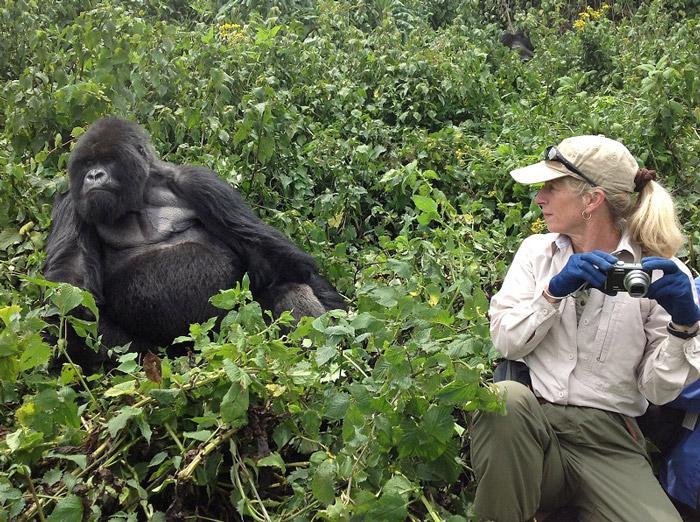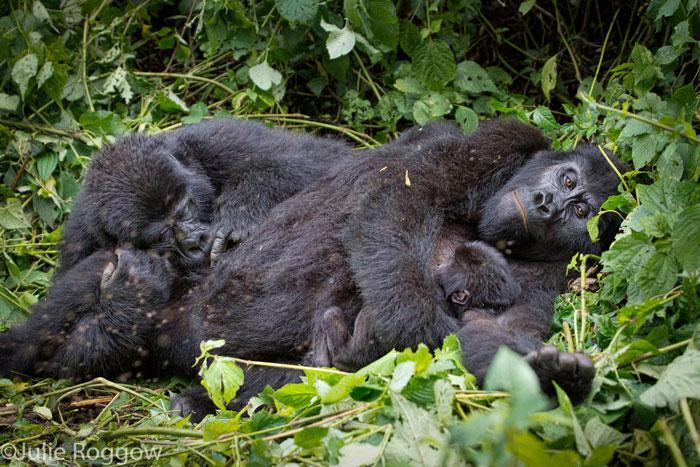The first image is the image on the left, the second image is the image on the right. Considering the images on both sides, is "A person holding a camera is near an adult gorilla in the left image." valid? Answer yes or no. Yes. The first image is the image on the left, the second image is the image on the right. Given the left and right images, does the statement "The left image contains a human interacting with a gorilla." hold true? Answer yes or no. Yes. 